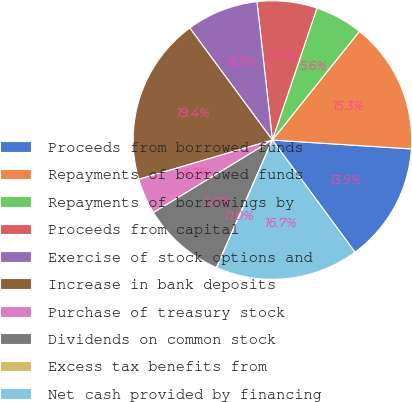<chart> <loc_0><loc_0><loc_500><loc_500><pie_chart><fcel>Proceeds from borrowed funds<fcel>Repayments of borrowed funds<fcel>Repayments of borrowings by<fcel>Proceeds from capital<fcel>Exercise of stock options and<fcel>Increase in bank deposits<fcel>Purchase of treasury stock<fcel>Dividends on common stock<fcel>Excess tax benefits from<fcel>Net cash provided by financing<nl><fcel>13.88%<fcel>15.27%<fcel>5.56%<fcel>6.95%<fcel>8.34%<fcel>19.43%<fcel>4.17%<fcel>9.72%<fcel>0.01%<fcel>16.66%<nl></chart> 